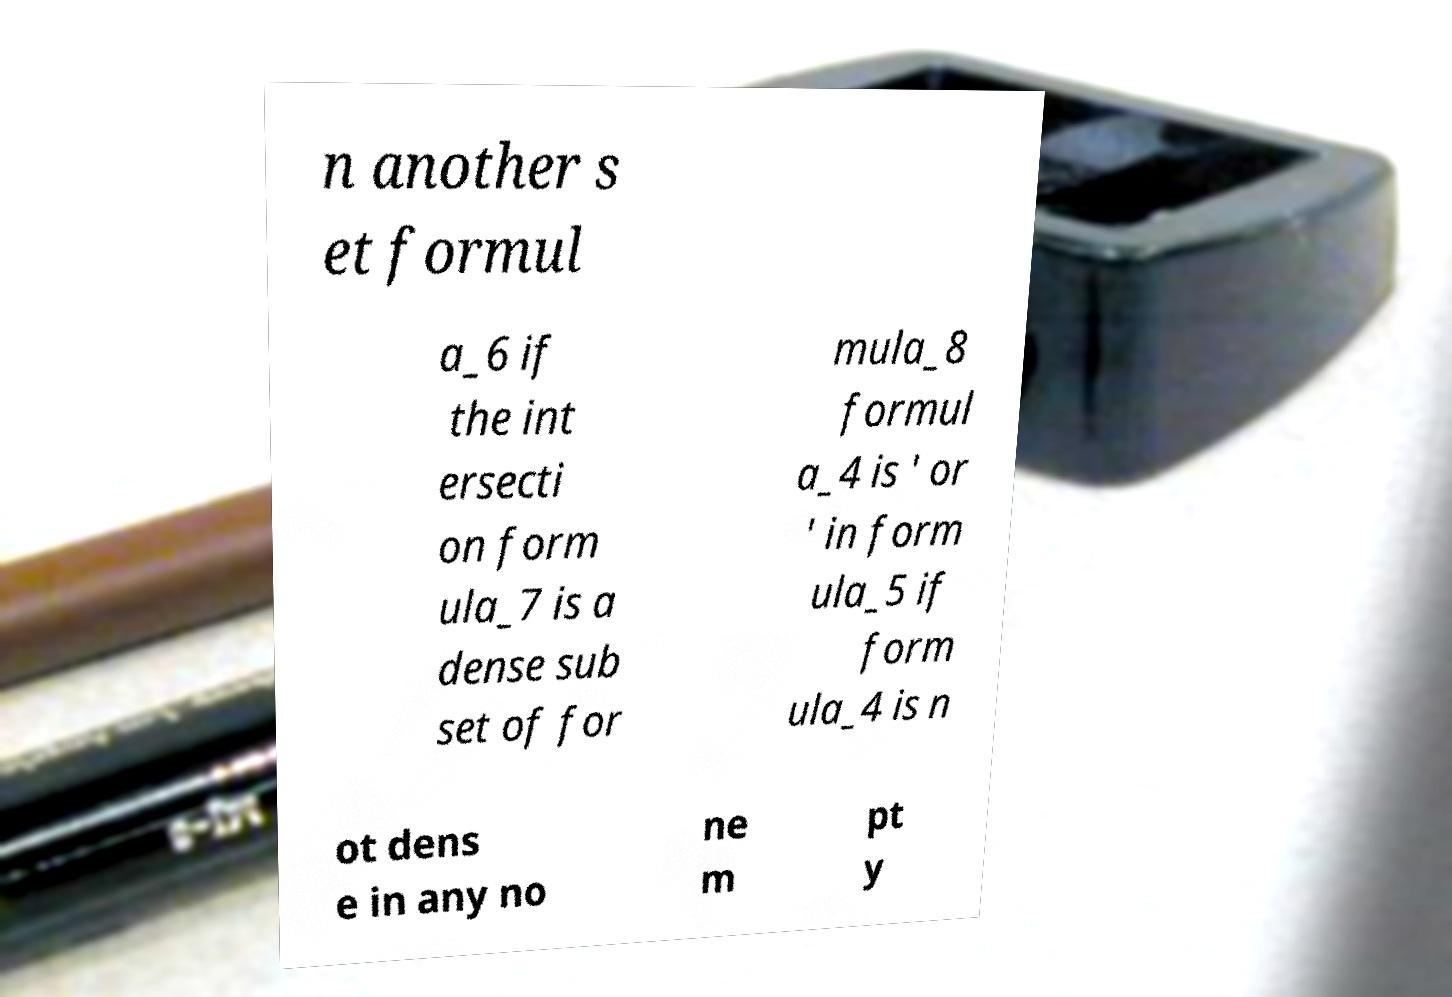I need the written content from this picture converted into text. Can you do that? n another s et formul a_6 if the int ersecti on form ula_7 is a dense sub set of for mula_8 formul a_4 is ' or ' in form ula_5 if form ula_4 is n ot dens e in any no ne m pt y 